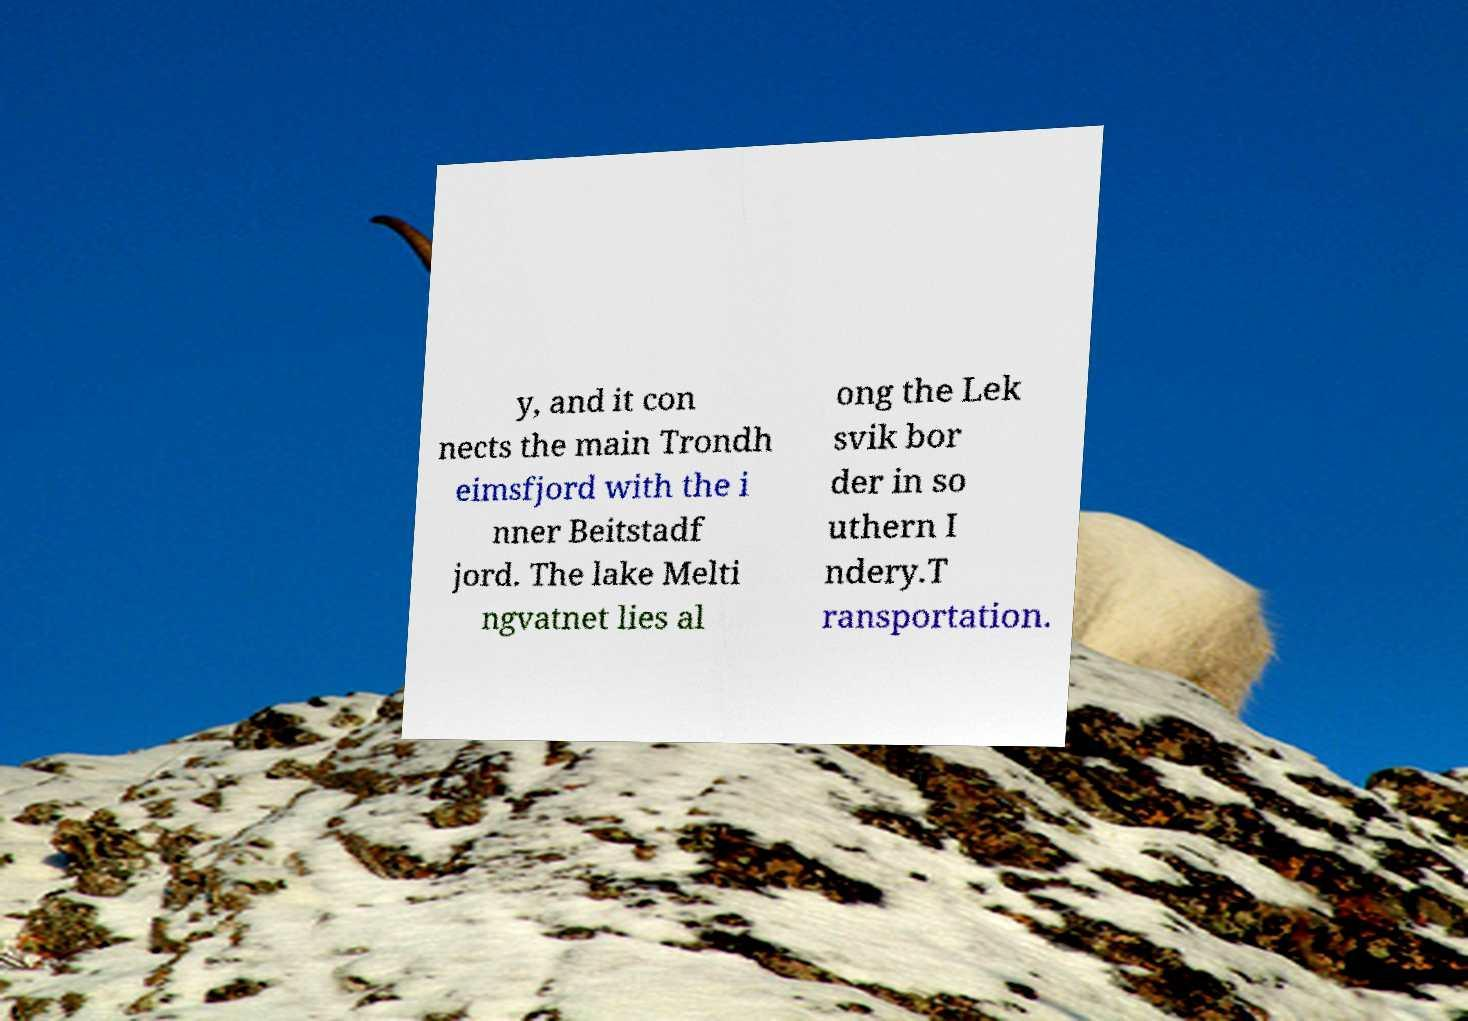Can you read and provide the text displayed in the image?This photo seems to have some interesting text. Can you extract and type it out for me? y, and it con nects the main Trondh eimsfjord with the i nner Beitstadf jord. The lake Melti ngvatnet lies al ong the Lek svik bor der in so uthern I ndery.T ransportation. 